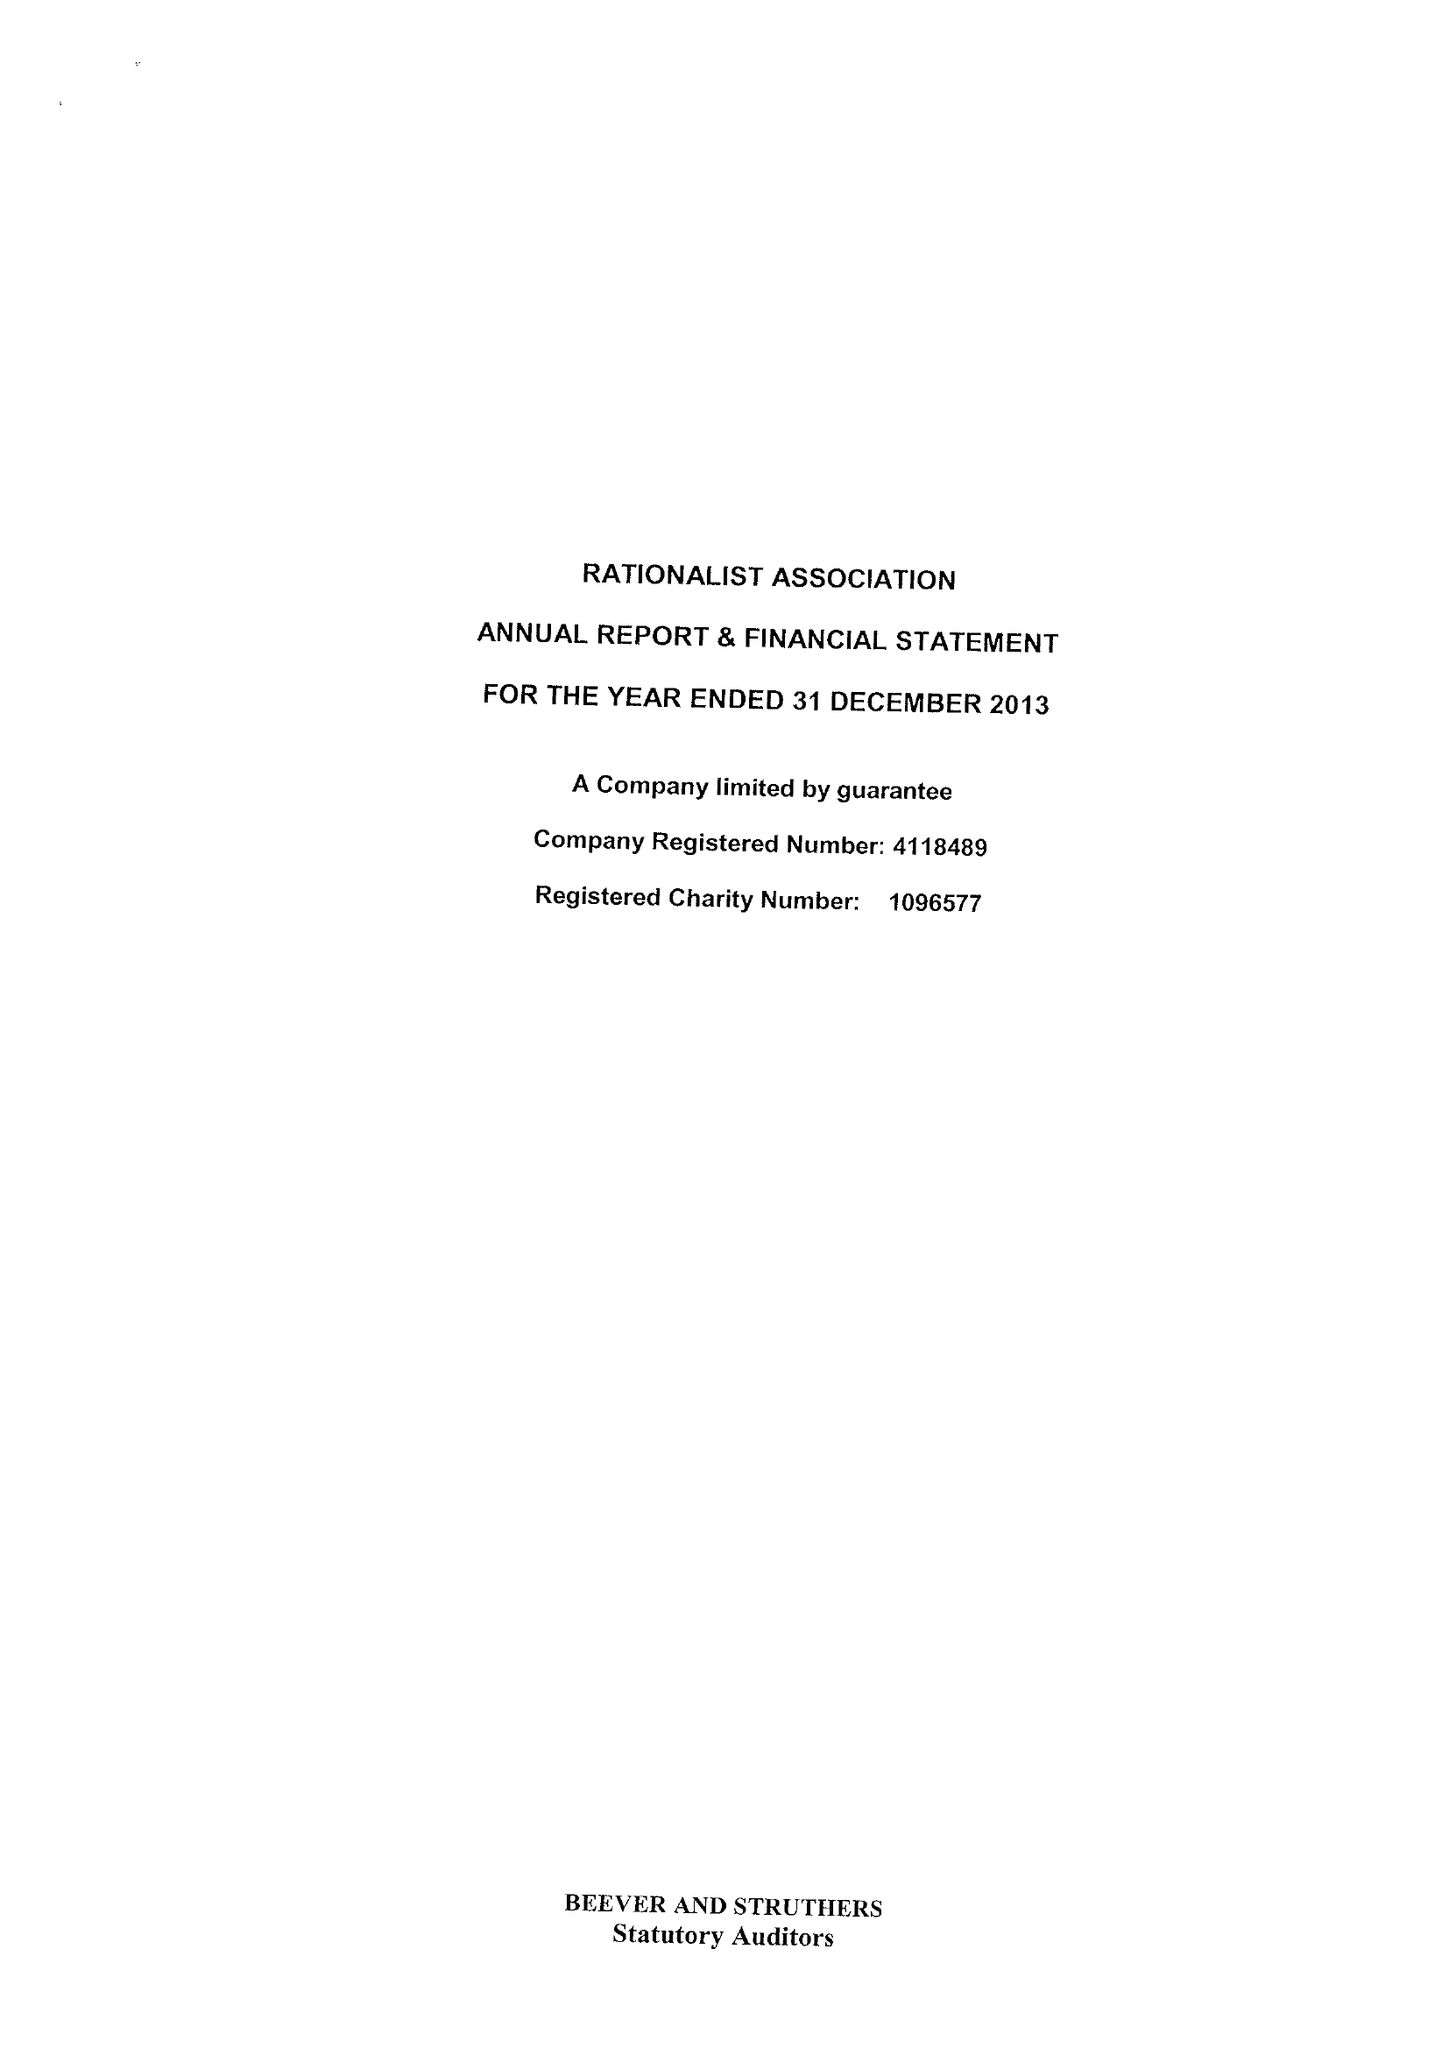What is the value for the address__post_town?
Answer the question using a single word or phrase. LONDON 